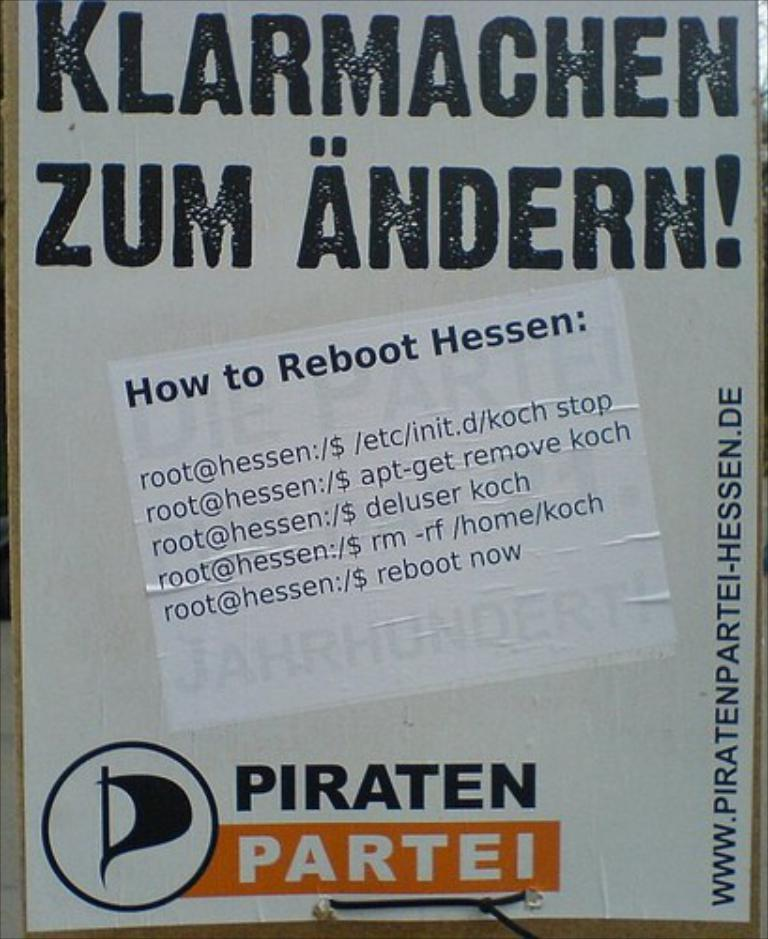<image>
Relay a brief, clear account of the picture shown. a paper with a message that has piraten at the bottom 